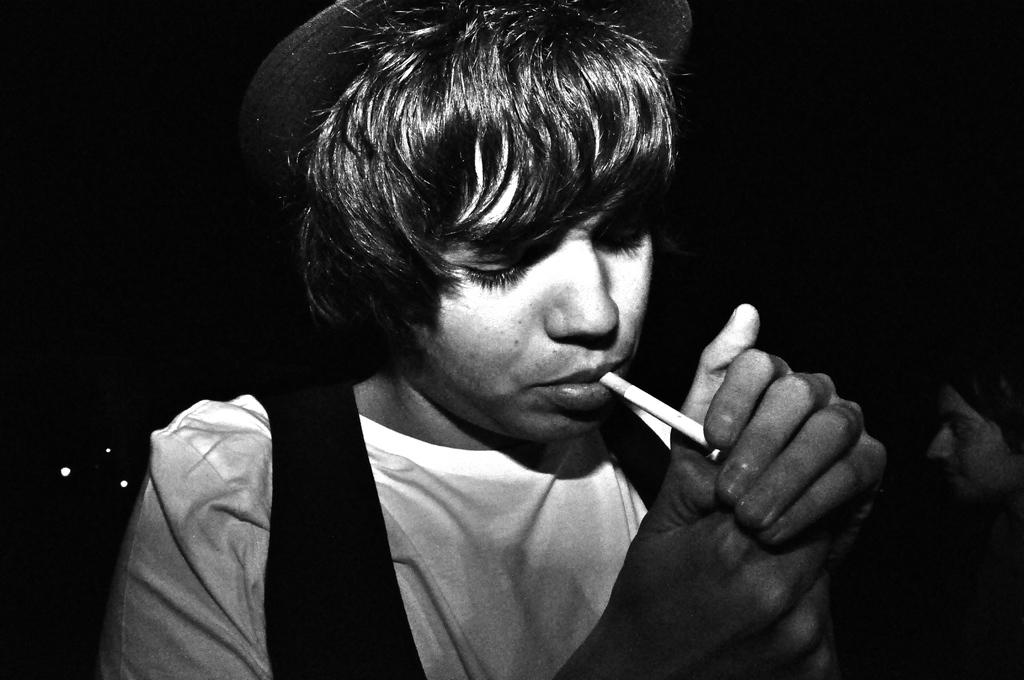Who is present in the image? There is a man in the image. What is the man wearing on his head? The man is wearing a hat. What activity is the man engaged in? The man is smoking. What can be observed about the lighting in the image? The background of the image is dark. Can you describe the presence of other people in the image? There is a person visible in the background of the image. What type of cork can be seen in the man's hand in the image? There is no cork visible in the man's hand or anywhere else in the image. What badge does the person in the background have on their shirt? There is no badge visible on the person in the background or on the man in the image. 